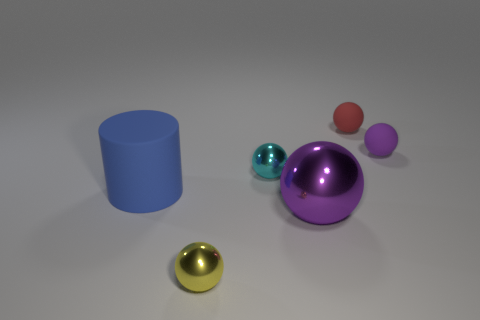Subtract all purple balls. How many balls are left? 3 Subtract all yellow cylinders. How many purple spheres are left? 2 Subtract 2 spheres. How many spheres are left? 3 Add 3 big blue cylinders. How many objects exist? 9 Subtract all cyan spheres. How many spheres are left? 4 Subtract all cylinders. How many objects are left? 5 Subtract all red balls. Subtract all yellow cylinders. How many balls are left? 4 Subtract all tiny rubber things. Subtract all cylinders. How many objects are left? 3 Add 1 big blue cylinders. How many big blue cylinders are left? 2 Add 6 small green blocks. How many small green blocks exist? 6 